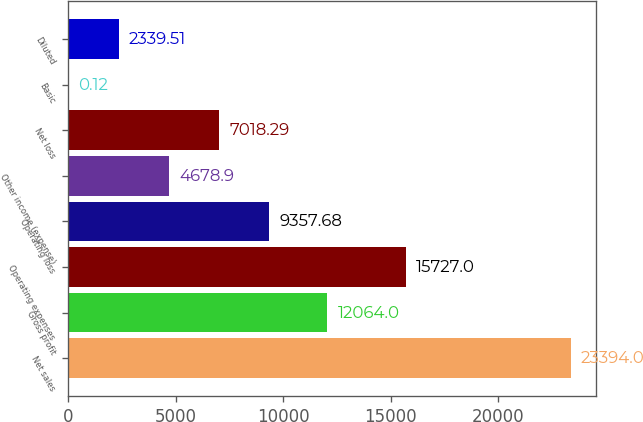Convert chart. <chart><loc_0><loc_0><loc_500><loc_500><bar_chart><fcel>Net sales<fcel>Gross profit<fcel>Operating expenses<fcel>Operating loss<fcel>Other income (expense)<fcel>Net loss<fcel>Basic<fcel>Diluted<nl><fcel>23394<fcel>12064<fcel>15727<fcel>9357.68<fcel>4678.9<fcel>7018.29<fcel>0.12<fcel>2339.51<nl></chart> 